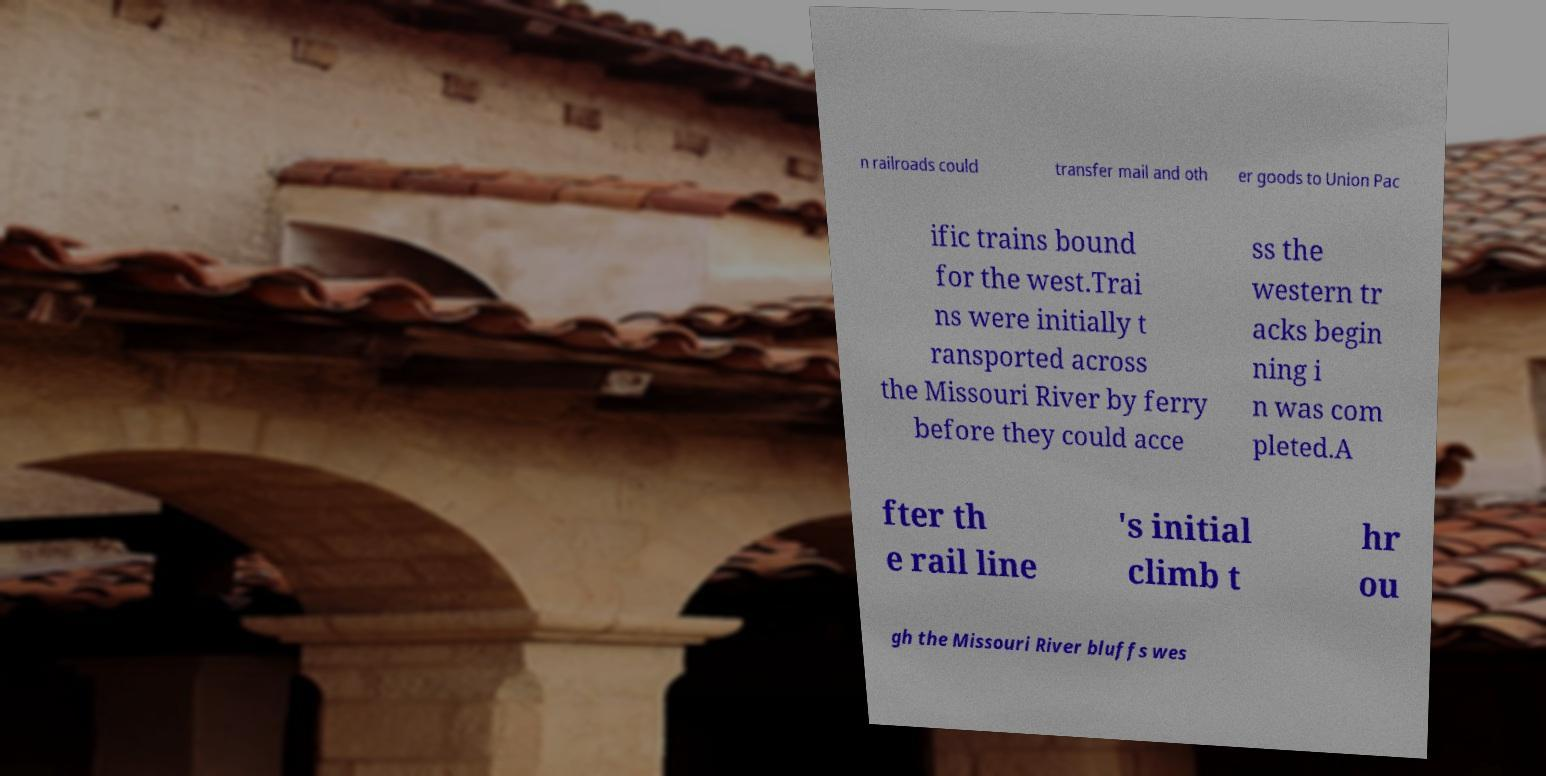Could you assist in decoding the text presented in this image and type it out clearly? n railroads could transfer mail and oth er goods to Union Pac ific trains bound for the west.Trai ns were initially t ransported across the Missouri River by ferry before they could acce ss the western tr acks begin ning i n was com pleted.A fter th e rail line 's initial climb t hr ou gh the Missouri River bluffs wes 